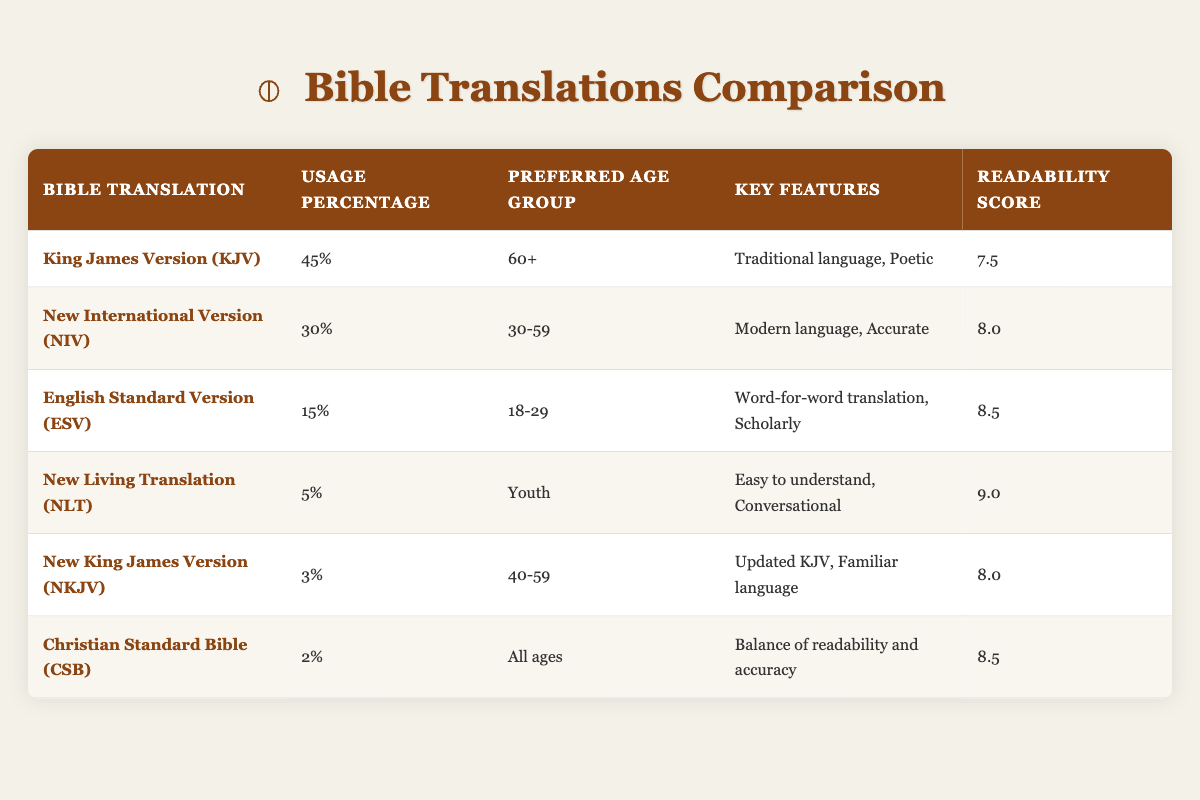What translation has the highest usage percentage? Looking at the "Usage Percentage" column, the King James Version (KJV) is listed with 45%, which is the highest among all translations in the table.
Answer: King James Version (KJV) Is the New International Version (NIV) preferred more by people aged 30-59? Yes, the preferred age group for the New International Version (NIV) is 30-59, and this information is explicitly stated in the table.
Answer: Yes What is the readability score of the New Living Translation (NLT)? The readability score for the New Living Translation (NLT) is found in the last column, where it indicates a score of 9.0.
Answer: 9.0 What is the combined usage percentage of the King James Version (KJV) and New International Version (NIV)? Adding the usage percentage of KJV (45%) and NIV (30%), we get 45 + 30 = 75%. Therefore, the combined usage percentage is 75%.
Answer: 75% Are there any translations preferred by all ages? Yes, the Christian Standard Bible (CSB) in the table is listed as being preferred by all ages.
Answer: Yes Which translation among the top three most used has the lowest readability score? The top three translations by usage are KJV (45%), NIV (30%), and ESV (15%). Among these, the King James Version (KJV) has a readability score of 7.5, while NIV has 8.0. ESV has 8.5, making KJV the lowest among them.
Answer: King James Version (KJV) How many translations have a readability score of 8.5 or higher? There are two translations with a readability score of 8.5 or higher: English Standard Version (ESV) and Christian Standard Bible (CSB), both scoring 8.5. Hence, the total count is 2.
Answer: 2 Which age group prefers the English Standard Version (ESV)? The table specifies that the English Standard Version (ESV) is preferred by the age group 18-29, as mentioned in the "Preferred Age Group" column.
Answer: 18-29 Is the readability score of New King James Version (NKJV) the same as that of New International Version (NIV)? No, the readability score for the New King James Version (NKJV) is 8.0, while the New International Version (NIV) has a score of 8.0 as well. Therefore, they are equal.
Answer: Yes 